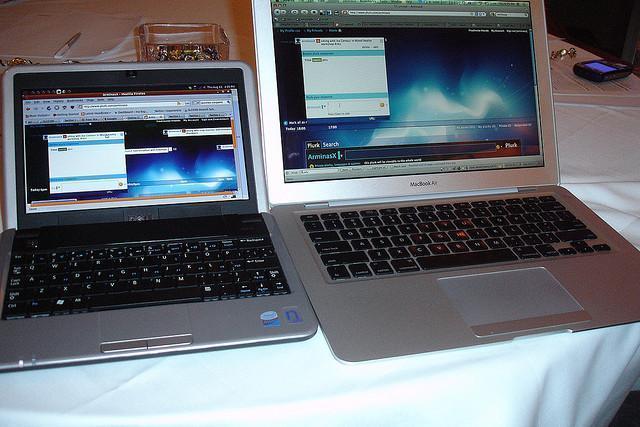What is side by side?
Make your selection from the four choices given to correctly answer the question.
Options: Babies, rabbits, laptops, cows. Laptops. 